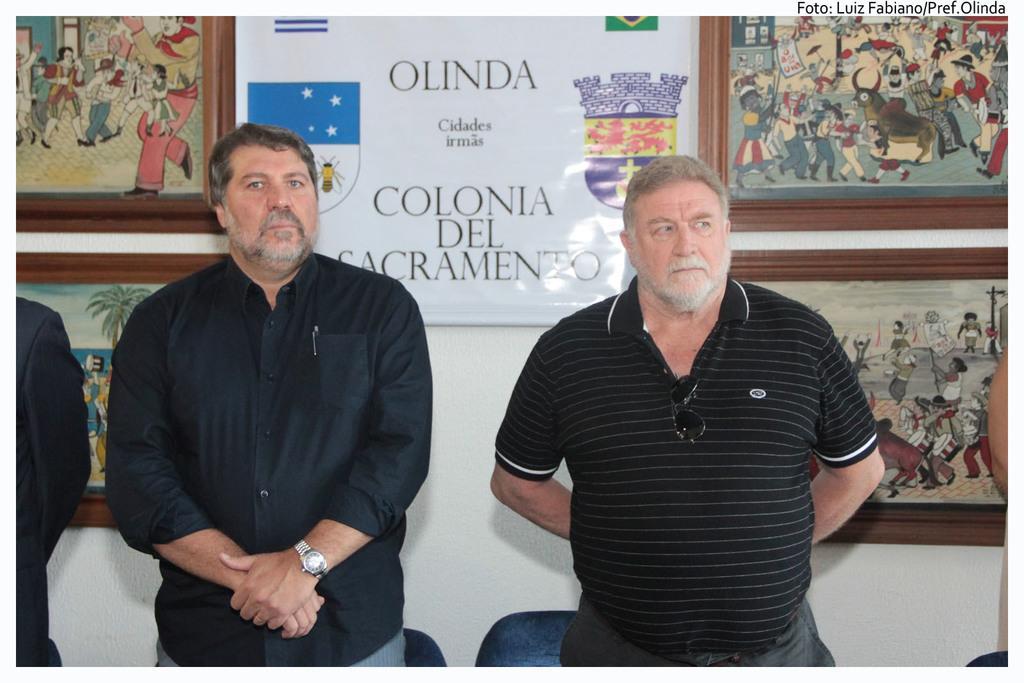How would you summarize this image in a sentence or two? In this image we can see two persons are standing, there are chairs, they are wearing the black dress, at the back there is a wall and photo frames on it. 